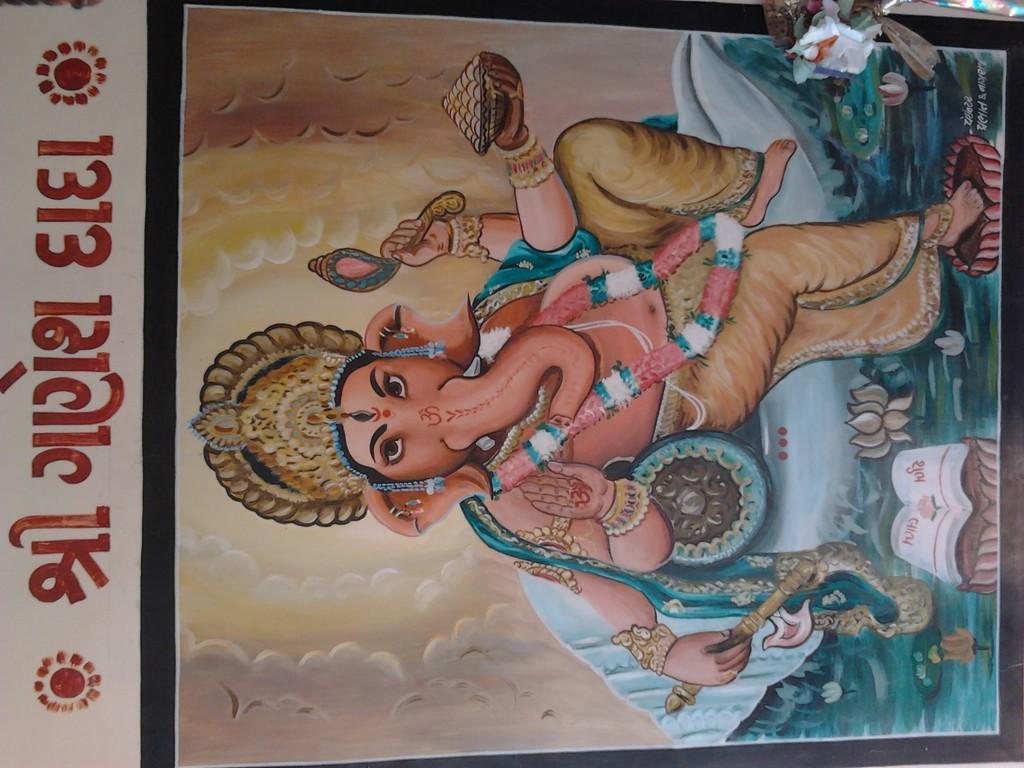How would you summarize this image in a sentence or two? In the center of the image a lord ganesha is there. On the left side of the image some text is present. 